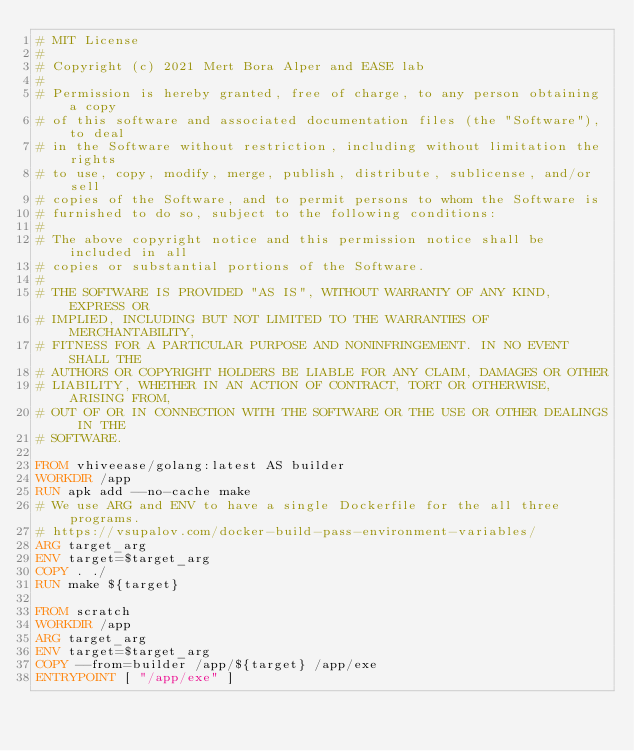Convert code to text. <code><loc_0><loc_0><loc_500><loc_500><_Dockerfile_># MIT License
#
# Copyright (c) 2021 Mert Bora Alper and EASE lab
#
# Permission is hereby granted, free of charge, to any person obtaining a copy
# of this software and associated documentation files (the "Software"), to deal
# in the Software without restriction, including without limitation the rights
# to use, copy, modify, merge, publish, distribute, sublicense, and/or sell
# copies of the Software, and to permit persons to whom the Software is
# furnished to do so, subject to the following conditions:
#
# The above copyright notice and this permission notice shall be included in all
# copies or substantial portions of the Software.
#
# THE SOFTWARE IS PROVIDED "AS IS", WITHOUT WARRANTY OF ANY KIND, EXPRESS OR
# IMPLIED, INCLUDING BUT NOT LIMITED TO THE WARRANTIES OF MERCHANTABILITY,
# FITNESS FOR A PARTICULAR PURPOSE AND NONINFRINGEMENT. IN NO EVENT SHALL THE
# AUTHORS OR COPYRIGHT HOLDERS BE LIABLE FOR ANY CLAIM, DAMAGES OR OTHER
# LIABILITY, WHETHER IN AN ACTION OF CONTRACT, TORT OR OTHERWISE, ARISING FROM,
# OUT OF OR IN CONNECTION WITH THE SOFTWARE OR THE USE OR OTHER DEALINGS IN THE
# SOFTWARE.

FROM vhiveease/golang:latest AS builder
WORKDIR /app
RUN apk add --no-cache make
# We use ARG and ENV to have a single Dockerfile for the all three programs.
# https://vsupalov.com/docker-build-pass-environment-variables/
ARG target_arg
ENV target=$target_arg
COPY . ./
RUN make ${target}

FROM scratch
WORKDIR /app
ARG target_arg
ENV target=$target_arg
COPY --from=builder /app/${target} /app/exe
ENTRYPOINT [ "/app/exe" ]
</code> 